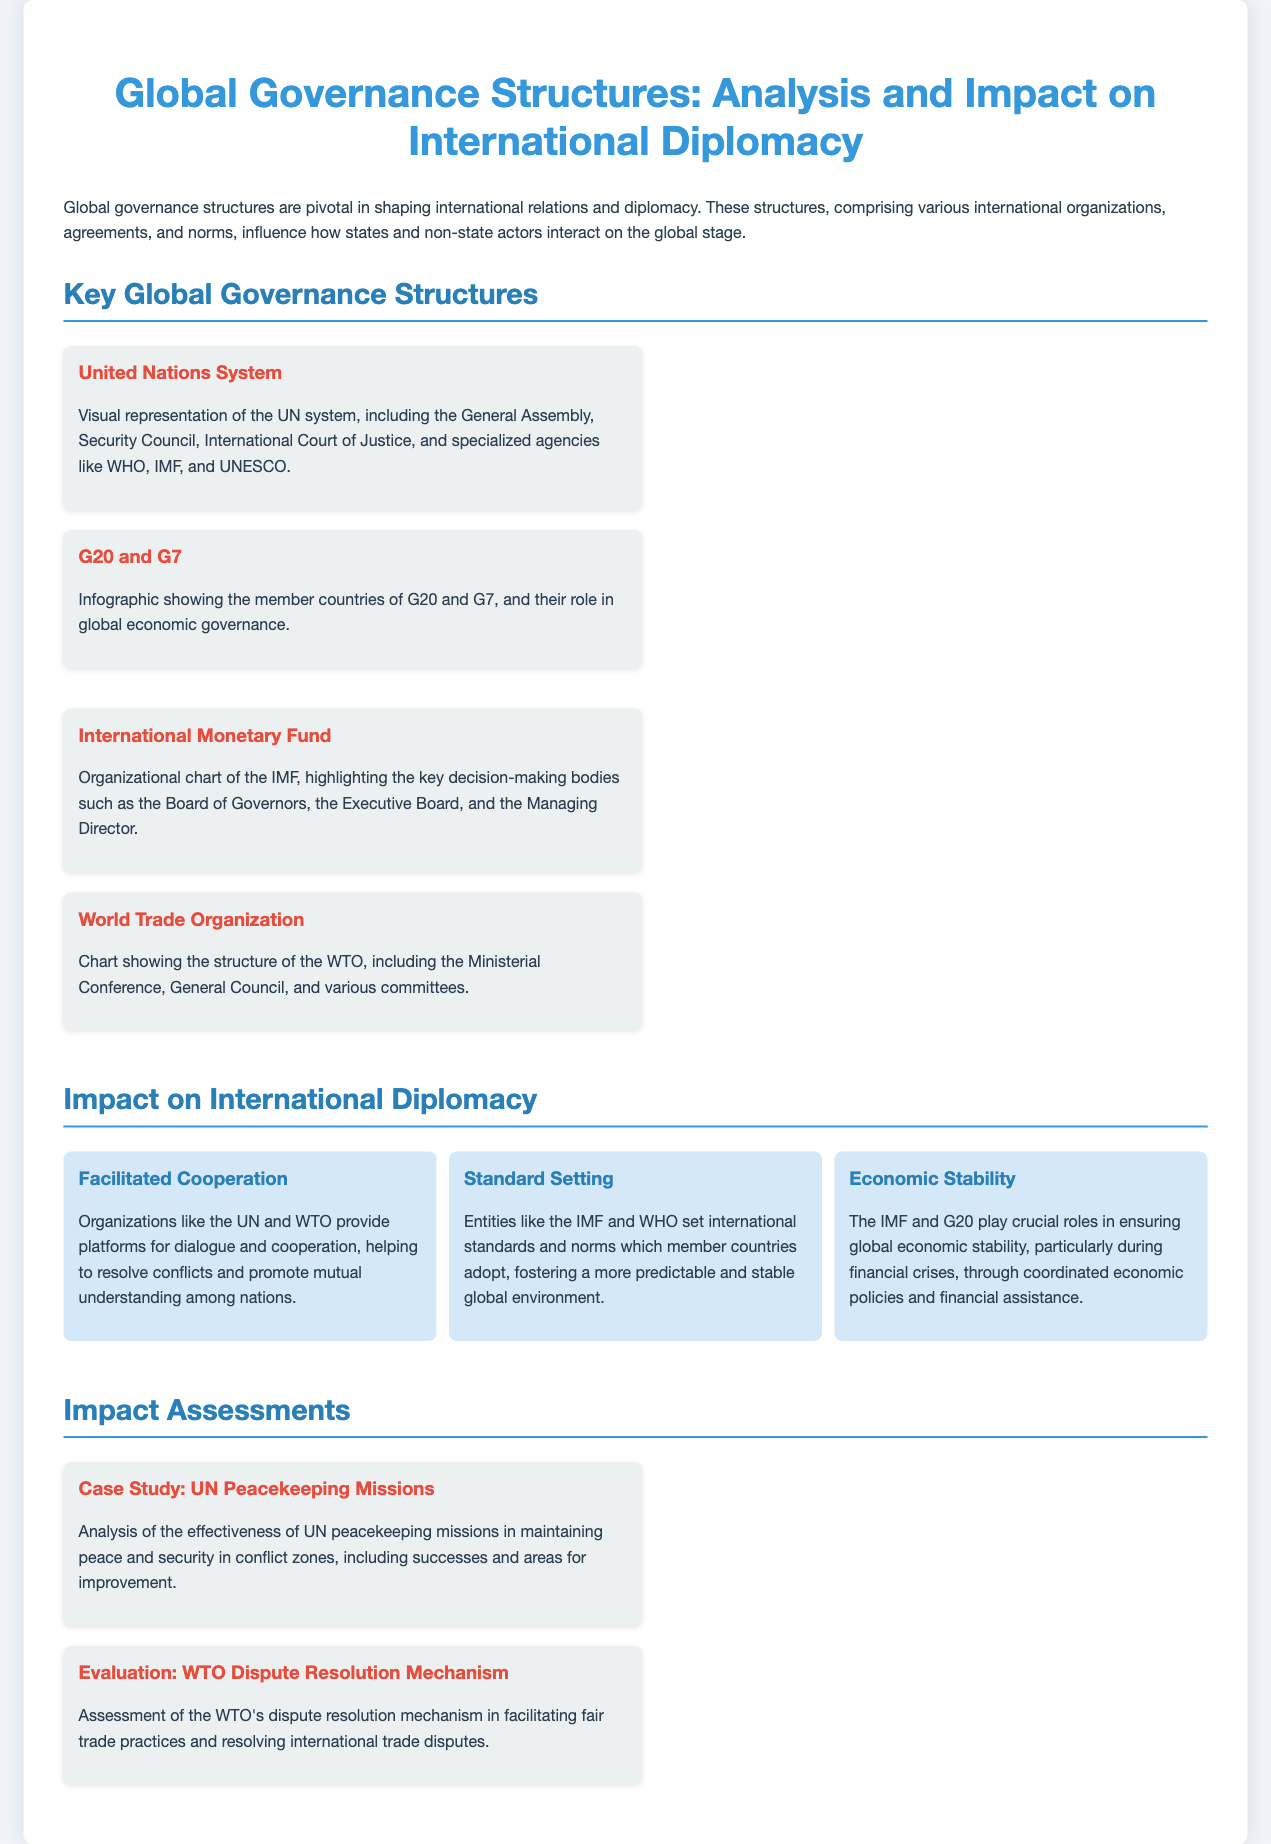What is the main focus of the presentation? The presentation focuses on the analysis and impact of global governance structures on international diplomacy.
Answer: Analysis and impact on international diplomacy Which organization is associated with peacekeeping missions? The document mentions UN peacekeeping missions as a key example of international governance structures.
Answer: UN What are the G20 and G7 primarily associated with? The G20 and G7 are primarily associated with global economic governance.
Answer: Global economic governance What role does the IMF play during financial crises? The IMF plays a crucial role in ensuring global economic stability during financial crises.
Answer: Ensuring global economic stability Which body is highlighted within the IMF structure? The Board of Governors is one of the key decision-making bodies within the IMF structure.
Answer: Board of Governors What type of standards does the WHO set? The WHO sets international health standards adopted by member countries.
Answer: International health standards What is one major outcome of the WTO's dispute resolution mechanism? It facilitates fair trade practices and resolves international trade disputes.
Answer: Fair trade practices Which organization's effectiveness is analyzed in the case study? The case study analyzes the effectiveness of UN peacekeeping missions.
Answer: UN peacekeeping missions What is emphasized as a significant impact of global governance structures? Facilitated cooperation among nations is emphasized as a significant impact.
Answer: Facilitated cooperation What visual representation is included in the presentation regarding the UN? A visual representation of the UN system is included.
Answer: UN system 